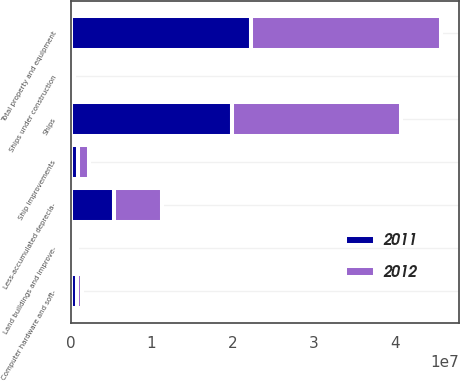Convert chart. <chart><loc_0><loc_0><loc_500><loc_500><stacked_bar_chart><ecel><fcel>Ships<fcel>Ship improvements<fcel>Ships under construction<fcel>Land buildings and improve-<fcel>Computer hardware and soft-<fcel>Total property and equipment<fcel>Less-accumulated deprecia-<nl><fcel>2012<fcel>2.08556e+07<fcel>1.34114e+06<fcel>169274<fcel>377821<fcel>698865<fcel>2.34427e+07<fcel>5.99167e+06<nl><fcel>2011<fcel>1.99581e+07<fcel>976363<fcel>227123<fcel>360399<fcel>748102<fcel>2.22701e+07<fcel>5.3353e+06<nl></chart> 